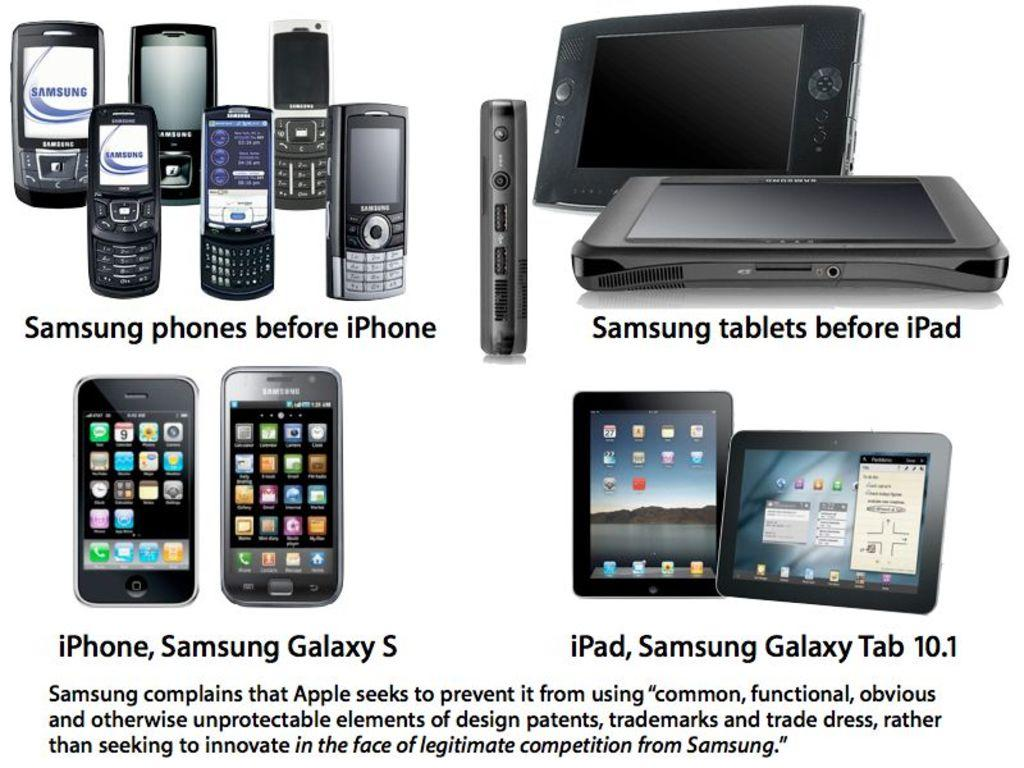<image>
Render a clear and concise summary of the photo. an iPhone is underneath a Samsung phone that is above 